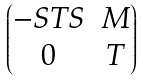<formula> <loc_0><loc_0><loc_500><loc_500>\begin{pmatrix} - S T S & M \\ 0 & T \end{pmatrix}</formula> 